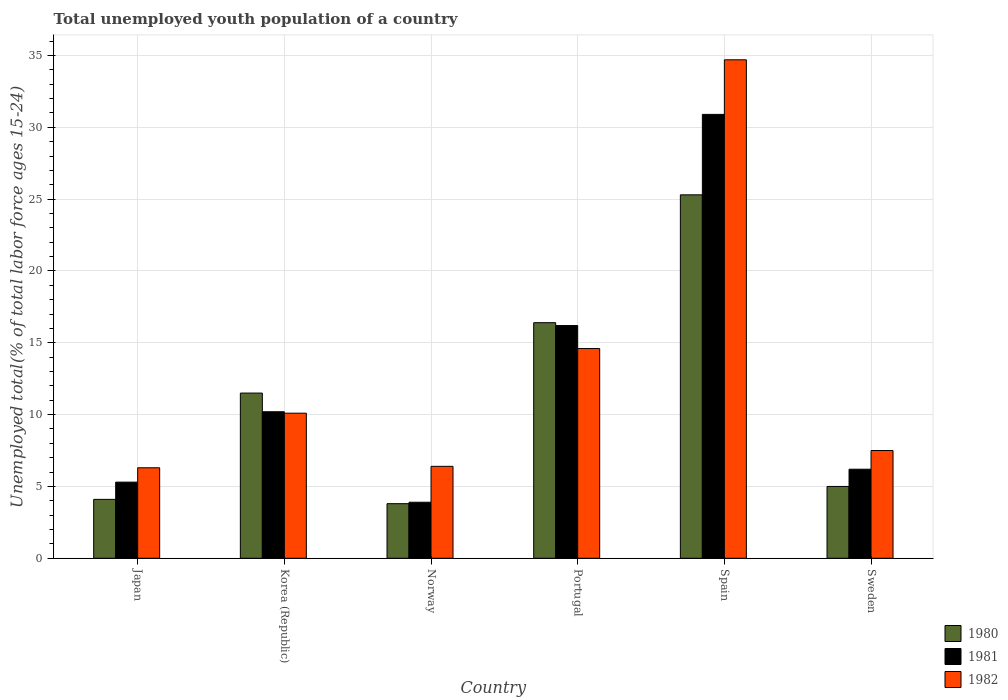How many different coloured bars are there?
Keep it short and to the point. 3. How many groups of bars are there?
Provide a short and direct response. 6. How many bars are there on the 3rd tick from the left?
Make the answer very short. 3. How many bars are there on the 3rd tick from the right?
Keep it short and to the point. 3. What is the percentage of total unemployed youth population of a country in 1981 in Japan?
Your answer should be compact. 5.3. Across all countries, what is the maximum percentage of total unemployed youth population of a country in 1982?
Offer a very short reply. 34.7. Across all countries, what is the minimum percentage of total unemployed youth population of a country in 1982?
Provide a short and direct response. 6.3. In which country was the percentage of total unemployed youth population of a country in 1982 minimum?
Provide a succinct answer. Japan. What is the total percentage of total unemployed youth population of a country in 1981 in the graph?
Offer a very short reply. 72.7. What is the difference between the percentage of total unemployed youth population of a country in 1981 in Korea (Republic) and that in Portugal?
Your answer should be very brief. -6. What is the difference between the percentage of total unemployed youth population of a country in 1981 in Spain and the percentage of total unemployed youth population of a country in 1980 in Korea (Republic)?
Give a very brief answer. 19.4. What is the average percentage of total unemployed youth population of a country in 1980 per country?
Keep it short and to the point. 11.02. What is the difference between the percentage of total unemployed youth population of a country of/in 1981 and percentage of total unemployed youth population of a country of/in 1980 in Korea (Republic)?
Provide a short and direct response. -1.3. In how many countries, is the percentage of total unemployed youth population of a country in 1981 greater than 8 %?
Your answer should be compact. 3. What is the ratio of the percentage of total unemployed youth population of a country in 1980 in Spain to that in Sweden?
Your answer should be very brief. 5.06. Is the difference between the percentage of total unemployed youth population of a country in 1981 in Spain and Sweden greater than the difference between the percentage of total unemployed youth population of a country in 1980 in Spain and Sweden?
Keep it short and to the point. Yes. What is the difference between the highest and the second highest percentage of total unemployed youth population of a country in 1981?
Your response must be concise. 6. What is the difference between the highest and the lowest percentage of total unemployed youth population of a country in 1982?
Your response must be concise. 28.4. What does the 3rd bar from the right in Sweden represents?
Provide a short and direct response. 1980. How many bars are there?
Offer a very short reply. 18. Does the graph contain grids?
Provide a short and direct response. Yes. Where does the legend appear in the graph?
Offer a very short reply. Bottom right. How many legend labels are there?
Offer a terse response. 3. What is the title of the graph?
Offer a terse response. Total unemployed youth population of a country. Does "2008" appear as one of the legend labels in the graph?
Your answer should be compact. No. What is the label or title of the X-axis?
Provide a short and direct response. Country. What is the label or title of the Y-axis?
Ensure brevity in your answer.  Unemployed total(% of total labor force ages 15-24). What is the Unemployed total(% of total labor force ages 15-24) of 1980 in Japan?
Offer a very short reply. 4.1. What is the Unemployed total(% of total labor force ages 15-24) of 1981 in Japan?
Your answer should be very brief. 5.3. What is the Unemployed total(% of total labor force ages 15-24) in 1982 in Japan?
Offer a very short reply. 6.3. What is the Unemployed total(% of total labor force ages 15-24) of 1980 in Korea (Republic)?
Provide a short and direct response. 11.5. What is the Unemployed total(% of total labor force ages 15-24) of 1981 in Korea (Republic)?
Give a very brief answer. 10.2. What is the Unemployed total(% of total labor force ages 15-24) of 1982 in Korea (Republic)?
Keep it short and to the point. 10.1. What is the Unemployed total(% of total labor force ages 15-24) in 1980 in Norway?
Your answer should be very brief. 3.8. What is the Unemployed total(% of total labor force ages 15-24) in 1981 in Norway?
Give a very brief answer. 3.9. What is the Unemployed total(% of total labor force ages 15-24) in 1982 in Norway?
Provide a short and direct response. 6.4. What is the Unemployed total(% of total labor force ages 15-24) of 1980 in Portugal?
Give a very brief answer. 16.4. What is the Unemployed total(% of total labor force ages 15-24) in 1981 in Portugal?
Your answer should be very brief. 16.2. What is the Unemployed total(% of total labor force ages 15-24) of 1982 in Portugal?
Offer a very short reply. 14.6. What is the Unemployed total(% of total labor force ages 15-24) of 1980 in Spain?
Make the answer very short. 25.3. What is the Unemployed total(% of total labor force ages 15-24) in 1981 in Spain?
Offer a very short reply. 30.9. What is the Unemployed total(% of total labor force ages 15-24) in 1982 in Spain?
Provide a short and direct response. 34.7. What is the Unemployed total(% of total labor force ages 15-24) in 1981 in Sweden?
Offer a very short reply. 6.2. Across all countries, what is the maximum Unemployed total(% of total labor force ages 15-24) in 1980?
Offer a terse response. 25.3. Across all countries, what is the maximum Unemployed total(% of total labor force ages 15-24) in 1981?
Your answer should be very brief. 30.9. Across all countries, what is the maximum Unemployed total(% of total labor force ages 15-24) in 1982?
Offer a terse response. 34.7. Across all countries, what is the minimum Unemployed total(% of total labor force ages 15-24) of 1980?
Give a very brief answer. 3.8. Across all countries, what is the minimum Unemployed total(% of total labor force ages 15-24) in 1981?
Your answer should be compact. 3.9. Across all countries, what is the minimum Unemployed total(% of total labor force ages 15-24) of 1982?
Offer a terse response. 6.3. What is the total Unemployed total(% of total labor force ages 15-24) of 1980 in the graph?
Keep it short and to the point. 66.1. What is the total Unemployed total(% of total labor force ages 15-24) in 1981 in the graph?
Provide a succinct answer. 72.7. What is the total Unemployed total(% of total labor force ages 15-24) of 1982 in the graph?
Your response must be concise. 79.6. What is the difference between the Unemployed total(% of total labor force ages 15-24) of 1980 in Japan and that in Korea (Republic)?
Offer a very short reply. -7.4. What is the difference between the Unemployed total(% of total labor force ages 15-24) of 1980 in Japan and that in Norway?
Keep it short and to the point. 0.3. What is the difference between the Unemployed total(% of total labor force ages 15-24) in 1981 in Japan and that in Norway?
Offer a terse response. 1.4. What is the difference between the Unemployed total(% of total labor force ages 15-24) in 1980 in Japan and that in Portugal?
Keep it short and to the point. -12.3. What is the difference between the Unemployed total(% of total labor force ages 15-24) in 1980 in Japan and that in Spain?
Your response must be concise. -21.2. What is the difference between the Unemployed total(% of total labor force ages 15-24) in 1981 in Japan and that in Spain?
Offer a terse response. -25.6. What is the difference between the Unemployed total(% of total labor force ages 15-24) of 1982 in Japan and that in Spain?
Your answer should be compact. -28.4. What is the difference between the Unemployed total(% of total labor force ages 15-24) of 1980 in Japan and that in Sweden?
Keep it short and to the point. -0.9. What is the difference between the Unemployed total(% of total labor force ages 15-24) of 1980 in Korea (Republic) and that in Norway?
Provide a succinct answer. 7.7. What is the difference between the Unemployed total(% of total labor force ages 15-24) of 1980 in Korea (Republic) and that in Portugal?
Your answer should be very brief. -4.9. What is the difference between the Unemployed total(% of total labor force ages 15-24) in 1981 in Korea (Republic) and that in Portugal?
Provide a short and direct response. -6. What is the difference between the Unemployed total(% of total labor force ages 15-24) of 1982 in Korea (Republic) and that in Portugal?
Keep it short and to the point. -4.5. What is the difference between the Unemployed total(% of total labor force ages 15-24) of 1980 in Korea (Republic) and that in Spain?
Keep it short and to the point. -13.8. What is the difference between the Unemployed total(% of total labor force ages 15-24) of 1981 in Korea (Republic) and that in Spain?
Ensure brevity in your answer.  -20.7. What is the difference between the Unemployed total(% of total labor force ages 15-24) in 1982 in Korea (Republic) and that in Spain?
Offer a terse response. -24.6. What is the difference between the Unemployed total(% of total labor force ages 15-24) in 1980 in Korea (Republic) and that in Sweden?
Your answer should be compact. 6.5. What is the difference between the Unemployed total(% of total labor force ages 15-24) in 1981 in Korea (Republic) and that in Sweden?
Ensure brevity in your answer.  4. What is the difference between the Unemployed total(% of total labor force ages 15-24) of 1980 in Norway and that in Spain?
Provide a succinct answer. -21.5. What is the difference between the Unemployed total(% of total labor force ages 15-24) of 1982 in Norway and that in Spain?
Offer a very short reply. -28.3. What is the difference between the Unemployed total(% of total labor force ages 15-24) of 1981 in Norway and that in Sweden?
Provide a short and direct response. -2.3. What is the difference between the Unemployed total(% of total labor force ages 15-24) of 1982 in Norway and that in Sweden?
Keep it short and to the point. -1.1. What is the difference between the Unemployed total(% of total labor force ages 15-24) of 1980 in Portugal and that in Spain?
Offer a very short reply. -8.9. What is the difference between the Unemployed total(% of total labor force ages 15-24) in 1981 in Portugal and that in Spain?
Your response must be concise. -14.7. What is the difference between the Unemployed total(% of total labor force ages 15-24) in 1982 in Portugal and that in Spain?
Keep it short and to the point. -20.1. What is the difference between the Unemployed total(% of total labor force ages 15-24) of 1981 in Portugal and that in Sweden?
Ensure brevity in your answer.  10. What is the difference between the Unemployed total(% of total labor force ages 15-24) in 1980 in Spain and that in Sweden?
Provide a short and direct response. 20.3. What is the difference between the Unemployed total(% of total labor force ages 15-24) of 1981 in Spain and that in Sweden?
Provide a short and direct response. 24.7. What is the difference between the Unemployed total(% of total labor force ages 15-24) in 1982 in Spain and that in Sweden?
Provide a succinct answer. 27.2. What is the difference between the Unemployed total(% of total labor force ages 15-24) in 1980 in Japan and the Unemployed total(% of total labor force ages 15-24) in 1982 in Korea (Republic)?
Offer a very short reply. -6. What is the difference between the Unemployed total(% of total labor force ages 15-24) of 1981 in Japan and the Unemployed total(% of total labor force ages 15-24) of 1982 in Korea (Republic)?
Offer a terse response. -4.8. What is the difference between the Unemployed total(% of total labor force ages 15-24) in 1980 in Japan and the Unemployed total(% of total labor force ages 15-24) in 1982 in Norway?
Provide a short and direct response. -2.3. What is the difference between the Unemployed total(% of total labor force ages 15-24) in 1981 in Japan and the Unemployed total(% of total labor force ages 15-24) in 1982 in Norway?
Your answer should be compact. -1.1. What is the difference between the Unemployed total(% of total labor force ages 15-24) of 1980 in Japan and the Unemployed total(% of total labor force ages 15-24) of 1982 in Portugal?
Ensure brevity in your answer.  -10.5. What is the difference between the Unemployed total(% of total labor force ages 15-24) of 1981 in Japan and the Unemployed total(% of total labor force ages 15-24) of 1982 in Portugal?
Offer a very short reply. -9.3. What is the difference between the Unemployed total(% of total labor force ages 15-24) in 1980 in Japan and the Unemployed total(% of total labor force ages 15-24) in 1981 in Spain?
Your answer should be compact. -26.8. What is the difference between the Unemployed total(% of total labor force ages 15-24) of 1980 in Japan and the Unemployed total(% of total labor force ages 15-24) of 1982 in Spain?
Give a very brief answer. -30.6. What is the difference between the Unemployed total(% of total labor force ages 15-24) in 1981 in Japan and the Unemployed total(% of total labor force ages 15-24) in 1982 in Spain?
Keep it short and to the point. -29.4. What is the difference between the Unemployed total(% of total labor force ages 15-24) in 1980 in Japan and the Unemployed total(% of total labor force ages 15-24) in 1982 in Sweden?
Your answer should be very brief. -3.4. What is the difference between the Unemployed total(% of total labor force ages 15-24) of 1980 in Korea (Republic) and the Unemployed total(% of total labor force ages 15-24) of 1981 in Norway?
Give a very brief answer. 7.6. What is the difference between the Unemployed total(% of total labor force ages 15-24) in 1980 in Korea (Republic) and the Unemployed total(% of total labor force ages 15-24) in 1982 in Norway?
Offer a very short reply. 5.1. What is the difference between the Unemployed total(% of total labor force ages 15-24) in 1981 in Korea (Republic) and the Unemployed total(% of total labor force ages 15-24) in 1982 in Norway?
Offer a very short reply. 3.8. What is the difference between the Unemployed total(% of total labor force ages 15-24) in 1980 in Korea (Republic) and the Unemployed total(% of total labor force ages 15-24) in 1981 in Portugal?
Your answer should be very brief. -4.7. What is the difference between the Unemployed total(% of total labor force ages 15-24) in 1980 in Korea (Republic) and the Unemployed total(% of total labor force ages 15-24) in 1981 in Spain?
Offer a terse response. -19.4. What is the difference between the Unemployed total(% of total labor force ages 15-24) in 1980 in Korea (Republic) and the Unemployed total(% of total labor force ages 15-24) in 1982 in Spain?
Your answer should be very brief. -23.2. What is the difference between the Unemployed total(% of total labor force ages 15-24) of 1981 in Korea (Republic) and the Unemployed total(% of total labor force ages 15-24) of 1982 in Spain?
Offer a very short reply. -24.5. What is the difference between the Unemployed total(% of total labor force ages 15-24) of 1980 in Korea (Republic) and the Unemployed total(% of total labor force ages 15-24) of 1981 in Sweden?
Make the answer very short. 5.3. What is the difference between the Unemployed total(% of total labor force ages 15-24) of 1981 in Norway and the Unemployed total(% of total labor force ages 15-24) of 1982 in Portugal?
Your answer should be compact. -10.7. What is the difference between the Unemployed total(% of total labor force ages 15-24) in 1980 in Norway and the Unemployed total(% of total labor force ages 15-24) in 1981 in Spain?
Offer a terse response. -27.1. What is the difference between the Unemployed total(% of total labor force ages 15-24) in 1980 in Norway and the Unemployed total(% of total labor force ages 15-24) in 1982 in Spain?
Keep it short and to the point. -30.9. What is the difference between the Unemployed total(% of total labor force ages 15-24) in 1981 in Norway and the Unemployed total(% of total labor force ages 15-24) in 1982 in Spain?
Ensure brevity in your answer.  -30.8. What is the difference between the Unemployed total(% of total labor force ages 15-24) of 1980 in Norway and the Unemployed total(% of total labor force ages 15-24) of 1981 in Sweden?
Make the answer very short. -2.4. What is the difference between the Unemployed total(% of total labor force ages 15-24) in 1981 in Norway and the Unemployed total(% of total labor force ages 15-24) in 1982 in Sweden?
Your answer should be very brief. -3.6. What is the difference between the Unemployed total(% of total labor force ages 15-24) of 1980 in Portugal and the Unemployed total(% of total labor force ages 15-24) of 1982 in Spain?
Ensure brevity in your answer.  -18.3. What is the difference between the Unemployed total(% of total labor force ages 15-24) in 1981 in Portugal and the Unemployed total(% of total labor force ages 15-24) in 1982 in Spain?
Give a very brief answer. -18.5. What is the difference between the Unemployed total(% of total labor force ages 15-24) in 1981 in Portugal and the Unemployed total(% of total labor force ages 15-24) in 1982 in Sweden?
Ensure brevity in your answer.  8.7. What is the difference between the Unemployed total(% of total labor force ages 15-24) of 1980 in Spain and the Unemployed total(% of total labor force ages 15-24) of 1981 in Sweden?
Ensure brevity in your answer.  19.1. What is the difference between the Unemployed total(% of total labor force ages 15-24) of 1980 in Spain and the Unemployed total(% of total labor force ages 15-24) of 1982 in Sweden?
Your answer should be compact. 17.8. What is the difference between the Unemployed total(% of total labor force ages 15-24) in 1981 in Spain and the Unemployed total(% of total labor force ages 15-24) in 1982 in Sweden?
Ensure brevity in your answer.  23.4. What is the average Unemployed total(% of total labor force ages 15-24) of 1980 per country?
Ensure brevity in your answer.  11.02. What is the average Unemployed total(% of total labor force ages 15-24) in 1981 per country?
Offer a very short reply. 12.12. What is the average Unemployed total(% of total labor force ages 15-24) of 1982 per country?
Offer a terse response. 13.27. What is the difference between the Unemployed total(% of total labor force ages 15-24) in 1981 and Unemployed total(% of total labor force ages 15-24) in 1982 in Japan?
Offer a terse response. -1. What is the difference between the Unemployed total(% of total labor force ages 15-24) in 1980 and Unemployed total(% of total labor force ages 15-24) in 1982 in Korea (Republic)?
Provide a succinct answer. 1.4. What is the difference between the Unemployed total(% of total labor force ages 15-24) in 1981 and Unemployed total(% of total labor force ages 15-24) in 1982 in Korea (Republic)?
Your response must be concise. 0.1. What is the difference between the Unemployed total(% of total labor force ages 15-24) in 1980 and Unemployed total(% of total labor force ages 15-24) in 1981 in Portugal?
Ensure brevity in your answer.  0.2. What is the difference between the Unemployed total(% of total labor force ages 15-24) of 1980 and Unemployed total(% of total labor force ages 15-24) of 1981 in Spain?
Keep it short and to the point. -5.6. What is the difference between the Unemployed total(% of total labor force ages 15-24) in 1980 and Unemployed total(% of total labor force ages 15-24) in 1982 in Spain?
Ensure brevity in your answer.  -9.4. What is the difference between the Unemployed total(% of total labor force ages 15-24) of 1981 and Unemployed total(% of total labor force ages 15-24) of 1982 in Spain?
Make the answer very short. -3.8. What is the difference between the Unemployed total(% of total labor force ages 15-24) of 1980 and Unemployed total(% of total labor force ages 15-24) of 1981 in Sweden?
Your answer should be compact. -1.2. What is the difference between the Unemployed total(% of total labor force ages 15-24) in 1981 and Unemployed total(% of total labor force ages 15-24) in 1982 in Sweden?
Offer a very short reply. -1.3. What is the ratio of the Unemployed total(% of total labor force ages 15-24) in 1980 in Japan to that in Korea (Republic)?
Your response must be concise. 0.36. What is the ratio of the Unemployed total(% of total labor force ages 15-24) of 1981 in Japan to that in Korea (Republic)?
Your answer should be compact. 0.52. What is the ratio of the Unemployed total(% of total labor force ages 15-24) in 1982 in Japan to that in Korea (Republic)?
Your answer should be compact. 0.62. What is the ratio of the Unemployed total(% of total labor force ages 15-24) in 1980 in Japan to that in Norway?
Your answer should be very brief. 1.08. What is the ratio of the Unemployed total(% of total labor force ages 15-24) in 1981 in Japan to that in Norway?
Give a very brief answer. 1.36. What is the ratio of the Unemployed total(% of total labor force ages 15-24) of 1982 in Japan to that in Norway?
Give a very brief answer. 0.98. What is the ratio of the Unemployed total(% of total labor force ages 15-24) in 1980 in Japan to that in Portugal?
Offer a very short reply. 0.25. What is the ratio of the Unemployed total(% of total labor force ages 15-24) in 1981 in Japan to that in Portugal?
Make the answer very short. 0.33. What is the ratio of the Unemployed total(% of total labor force ages 15-24) of 1982 in Japan to that in Portugal?
Offer a terse response. 0.43. What is the ratio of the Unemployed total(% of total labor force ages 15-24) in 1980 in Japan to that in Spain?
Give a very brief answer. 0.16. What is the ratio of the Unemployed total(% of total labor force ages 15-24) of 1981 in Japan to that in Spain?
Make the answer very short. 0.17. What is the ratio of the Unemployed total(% of total labor force ages 15-24) in 1982 in Japan to that in Spain?
Offer a terse response. 0.18. What is the ratio of the Unemployed total(% of total labor force ages 15-24) in 1980 in Japan to that in Sweden?
Your response must be concise. 0.82. What is the ratio of the Unemployed total(% of total labor force ages 15-24) of 1981 in Japan to that in Sweden?
Your response must be concise. 0.85. What is the ratio of the Unemployed total(% of total labor force ages 15-24) in 1982 in Japan to that in Sweden?
Offer a terse response. 0.84. What is the ratio of the Unemployed total(% of total labor force ages 15-24) of 1980 in Korea (Republic) to that in Norway?
Keep it short and to the point. 3.03. What is the ratio of the Unemployed total(% of total labor force ages 15-24) of 1981 in Korea (Republic) to that in Norway?
Your answer should be very brief. 2.62. What is the ratio of the Unemployed total(% of total labor force ages 15-24) in 1982 in Korea (Republic) to that in Norway?
Offer a very short reply. 1.58. What is the ratio of the Unemployed total(% of total labor force ages 15-24) of 1980 in Korea (Republic) to that in Portugal?
Ensure brevity in your answer.  0.7. What is the ratio of the Unemployed total(% of total labor force ages 15-24) in 1981 in Korea (Republic) to that in Portugal?
Your answer should be compact. 0.63. What is the ratio of the Unemployed total(% of total labor force ages 15-24) of 1982 in Korea (Republic) to that in Portugal?
Your answer should be very brief. 0.69. What is the ratio of the Unemployed total(% of total labor force ages 15-24) of 1980 in Korea (Republic) to that in Spain?
Ensure brevity in your answer.  0.45. What is the ratio of the Unemployed total(% of total labor force ages 15-24) in 1981 in Korea (Republic) to that in Spain?
Offer a terse response. 0.33. What is the ratio of the Unemployed total(% of total labor force ages 15-24) in 1982 in Korea (Republic) to that in Spain?
Give a very brief answer. 0.29. What is the ratio of the Unemployed total(% of total labor force ages 15-24) of 1981 in Korea (Republic) to that in Sweden?
Ensure brevity in your answer.  1.65. What is the ratio of the Unemployed total(% of total labor force ages 15-24) in 1982 in Korea (Republic) to that in Sweden?
Offer a very short reply. 1.35. What is the ratio of the Unemployed total(% of total labor force ages 15-24) of 1980 in Norway to that in Portugal?
Your answer should be very brief. 0.23. What is the ratio of the Unemployed total(% of total labor force ages 15-24) of 1981 in Norway to that in Portugal?
Make the answer very short. 0.24. What is the ratio of the Unemployed total(% of total labor force ages 15-24) of 1982 in Norway to that in Portugal?
Keep it short and to the point. 0.44. What is the ratio of the Unemployed total(% of total labor force ages 15-24) of 1980 in Norway to that in Spain?
Offer a very short reply. 0.15. What is the ratio of the Unemployed total(% of total labor force ages 15-24) in 1981 in Norway to that in Spain?
Give a very brief answer. 0.13. What is the ratio of the Unemployed total(% of total labor force ages 15-24) in 1982 in Norway to that in Spain?
Provide a short and direct response. 0.18. What is the ratio of the Unemployed total(% of total labor force ages 15-24) of 1980 in Norway to that in Sweden?
Provide a short and direct response. 0.76. What is the ratio of the Unemployed total(% of total labor force ages 15-24) of 1981 in Norway to that in Sweden?
Your answer should be very brief. 0.63. What is the ratio of the Unemployed total(% of total labor force ages 15-24) of 1982 in Norway to that in Sweden?
Make the answer very short. 0.85. What is the ratio of the Unemployed total(% of total labor force ages 15-24) in 1980 in Portugal to that in Spain?
Your answer should be compact. 0.65. What is the ratio of the Unemployed total(% of total labor force ages 15-24) in 1981 in Portugal to that in Spain?
Provide a short and direct response. 0.52. What is the ratio of the Unemployed total(% of total labor force ages 15-24) of 1982 in Portugal to that in Spain?
Your response must be concise. 0.42. What is the ratio of the Unemployed total(% of total labor force ages 15-24) in 1980 in Portugal to that in Sweden?
Your answer should be very brief. 3.28. What is the ratio of the Unemployed total(% of total labor force ages 15-24) of 1981 in Portugal to that in Sweden?
Give a very brief answer. 2.61. What is the ratio of the Unemployed total(% of total labor force ages 15-24) in 1982 in Portugal to that in Sweden?
Provide a short and direct response. 1.95. What is the ratio of the Unemployed total(% of total labor force ages 15-24) in 1980 in Spain to that in Sweden?
Your answer should be compact. 5.06. What is the ratio of the Unemployed total(% of total labor force ages 15-24) of 1981 in Spain to that in Sweden?
Provide a short and direct response. 4.98. What is the ratio of the Unemployed total(% of total labor force ages 15-24) in 1982 in Spain to that in Sweden?
Provide a succinct answer. 4.63. What is the difference between the highest and the second highest Unemployed total(% of total labor force ages 15-24) in 1980?
Provide a succinct answer. 8.9. What is the difference between the highest and the second highest Unemployed total(% of total labor force ages 15-24) in 1981?
Give a very brief answer. 14.7. What is the difference between the highest and the second highest Unemployed total(% of total labor force ages 15-24) in 1982?
Provide a short and direct response. 20.1. What is the difference between the highest and the lowest Unemployed total(% of total labor force ages 15-24) of 1982?
Make the answer very short. 28.4. 